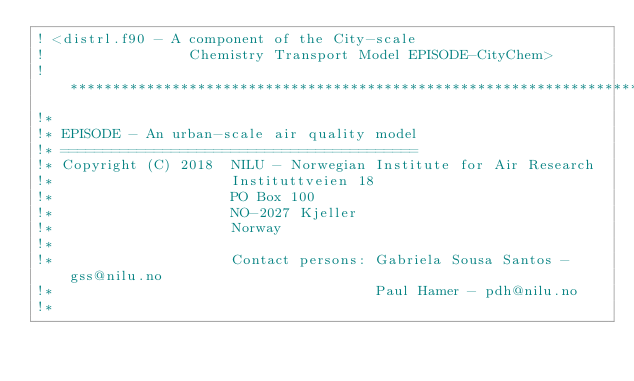Convert code to text. <code><loc_0><loc_0><loc_500><loc_500><_FORTRAN_>! <distrl.f90 - A component of the City-scale
!                 Chemistry Transport Model EPISODE-CityChem>
!*****************************************************************************! 
!* 
!* EPISODE - An urban-scale air quality model
!* ========================================== 
!* Copyright (C) 2018  NILU - Norwegian Institute for Air Research
!*                     Instituttveien 18
!*                     PO Box 100
!*                     NO-2027 Kjeller
!*                     Norway
!*
!*                     Contact persons: Gabriela Sousa Santos - gss@nilu.no
!*                                      Paul Hamer - pdh@nilu.no
!*</code> 